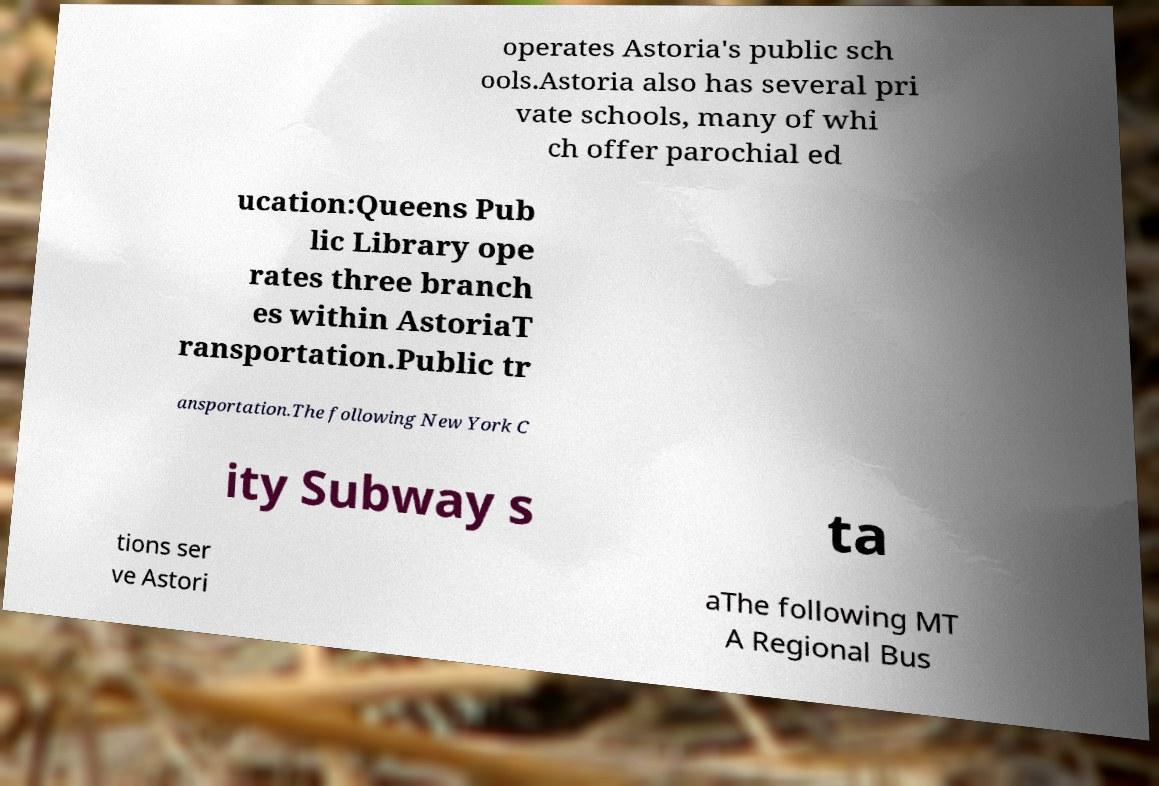Please identify and transcribe the text found in this image. operates Astoria's public sch ools.Astoria also has several pri vate schools, many of whi ch offer parochial ed ucation:Queens Pub lic Library ope rates three branch es within AstoriaT ransportation.Public tr ansportation.The following New York C ity Subway s ta tions ser ve Astori aThe following MT A Regional Bus 